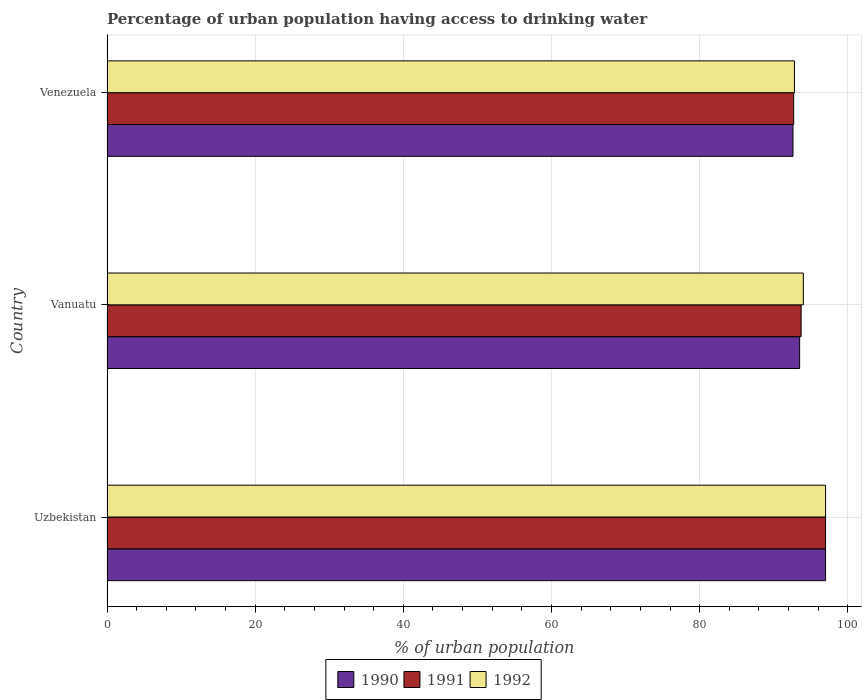What is the label of the 3rd group of bars from the top?
Make the answer very short. Uzbekistan. In how many cases, is the number of bars for a given country not equal to the number of legend labels?
Provide a short and direct response. 0. What is the percentage of urban population having access to drinking water in 1990 in Venezuela?
Your answer should be very brief. 92.6. Across all countries, what is the maximum percentage of urban population having access to drinking water in 1991?
Provide a short and direct response. 97. Across all countries, what is the minimum percentage of urban population having access to drinking water in 1990?
Your response must be concise. 92.6. In which country was the percentage of urban population having access to drinking water in 1991 maximum?
Ensure brevity in your answer.  Uzbekistan. In which country was the percentage of urban population having access to drinking water in 1990 minimum?
Provide a succinct answer. Venezuela. What is the total percentage of urban population having access to drinking water in 1990 in the graph?
Offer a terse response. 283.1. What is the difference between the percentage of urban population having access to drinking water in 1991 in Uzbekistan and the percentage of urban population having access to drinking water in 1992 in Venezuela?
Your answer should be compact. 4.2. What is the average percentage of urban population having access to drinking water in 1991 per country?
Your answer should be very brief. 94.47. What is the ratio of the percentage of urban population having access to drinking water in 1991 in Uzbekistan to that in Venezuela?
Your answer should be compact. 1.05. Is the percentage of urban population having access to drinking water in 1991 in Uzbekistan less than that in Venezuela?
Keep it short and to the point. No. Is the difference between the percentage of urban population having access to drinking water in 1992 in Vanuatu and Venezuela greater than the difference between the percentage of urban population having access to drinking water in 1990 in Vanuatu and Venezuela?
Offer a terse response. Yes. What is the difference between the highest and the second highest percentage of urban population having access to drinking water in 1992?
Make the answer very short. 3. What is the difference between the highest and the lowest percentage of urban population having access to drinking water in 1992?
Offer a very short reply. 4.2. How many countries are there in the graph?
Offer a very short reply. 3. Are the values on the major ticks of X-axis written in scientific E-notation?
Offer a terse response. No. Does the graph contain grids?
Ensure brevity in your answer.  Yes. How many legend labels are there?
Your answer should be compact. 3. What is the title of the graph?
Provide a succinct answer. Percentage of urban population having access to drinking water. Does "1971" appear as one of the legend labels in the graph?
Your response must be concise. No. What is the label or title of the X-axis?
Make the answer very short. % of urban population. What is the label or title of the Y-axis?
Your answer should be compact. Country. What is the % of urban population of 1990 in Uzbekistan?
Provide a succinct answer. 97. What is the % of urban population of 1991 in Uzbekistan?
Give a very brief answer. 97. What is the % of urban population in 1992 in Uzbekistan?
Make the answer very short. 97. What is the % of urban population of 1990 in Vanuatu?
Ensure brevity in your answer.  93.5. What is the % of urban population in 1991 in Vanuatu?
Your response must be concise. 93.7. What is the % of urban population of 1992 in Vanuatu?
Make the answer very short. 94. What is the % of urban population of 1990 in Venezuela?
Offer a very short reply. 92.6. What is the % of urban population in 1991 in Venezuela?
Your response must be concise. 92.7. What is the % of urban population in 1992 in Venezuela?
Make the answer very short. 92.8. Across all countries, what is the maximum % of urban population in 1990?
Your answer should be very brief. 97. Across all countries, what is the maximum % of urban population of 1991?
Provide a short and direct response. 97. Across all countries, what is the maximum % of urban population in 1992?
Your answer should be very brief. 97. Across all countries, what is the minimum % of urban population in 1990?
Keep it short and to the point. 92.6. Across all countries, what is the minimum % of urban population of 1991?
Provide a short and direct response. 92.7. Across all countries, what is the minimum % of urban population of 1992?
Your answer should be compact. 92.8. What is the total % of urban population of 1990 in the graph?
Ensure brevity in your answer.  283.1. What is the total % of urban population in 1991 in the graph?
Ensure brevity in your answer.  283.4. What is the total % of urban population of 1992 in the graph?
Your answer should be very brief. 283.8. What is the difference between the % of urban population of 1990 in Uzbekistan and that in Venezuela?
Your answer should be compact. 4.4. What is the difference between the % of urban population in 1991 in Vanuatu and that in Venezuela?
Provide a succinct answer. 1. What is the difference between the % of urban population of 1990 in Uzbekistan and the % of urban population of 1991 in Vanuatu?
Your response must be concise. 3.3. What is the difference between the % of urban population in 1991 in Uzbekistan and the % of urban population in 1992 in Vanuatu?
Give a very brief answer. 3. What is the difference between the % of urban population in 1990 in Uzbekistan and the % of urban population in 1991 in Venezuela?
Your answer should be very brief. 4.3. What is the difference between the % of urban population in 1990 in Uzbekistan and the % of urban population in 1992 in Venezuela?
Keep it short and to the point. 4.2. What is the difference between the % of urban population in 1991 in Uzbekistan and the % of urban population in 1992 in Venezuela?
Provide a succinct answer. 4.2. What is the difference between the % of urban population in 1990 in Vanuatu and the % of urban population in 1992 in Venezuela?
Your answer should be very brief. 0.7. What is the average % of urban population in 1990 per country?
Give a very brief answer. 94.37. What is the average % of urban population in 1991 per country?
Offer a terse response. 94.47. What is the average % of urban population in 1992 per country?
Make the answer very short. 94.6. What is the difference between the % of urban population of 1991 and % of urban population of 1992 in Uzbekistan?
Provide a succinct answer. 0. What is the difference between the % of urban population of 1990 and % of urban population of 1992 in Venezuela?
Give a very brief answer. -0.2. What is the ratio of the % of urban population of 1990 in Uzbekistan to that in Vanuatu?
Provide a short and direct response. 1.04. What is the ratio of the % of urban population in 1991 in Uzbekistan to that in Vanuatu?
Your answer should be compact. 1.04. What is the ratio of the % of urban population of 1992 in Uzbekistan to that in Vanuatu?
Ensure brevity in your answer.  1.03. What is the ratio of the % of urban population of 1990 in Uzbekistan to that in Venezuela?
Provide a short and direct response. 1.05. What is the ratio of the % of urban population of 1991 in Uzbekistan to that in Venezuela?
Your answer should be compact. 1.05. What is the ratio of the % of urban population of 1992 in Uzbekistan to that in Venezuela?
Provide a short and direct response. 1.05. What is the ratio of the % of urban population in 1990 in Vanuatu to that in Venezuela?
Provide a succinct answer. 1.01. What is the ratio of the % of urban population of 1991 in Vanuatu to that in Venezuela?
Provide a succinct answer. 1.01. What is the ratio of the % of urban population in 1992 in Vanuatu to that in Venezuela?
Give a very brief answer. 1.01. What is the difference between the highest and the second highest % of urban population of 1991?
Provide a short and direct response. 3.3. What is the difference between the highest and the second highest % of urban population in 1992?
Give a very brief answer. 3. What is the difference between the highest and the lowest % of urban population of 1990?
Your response must be concise. 4.4. What is the difference between the highest and the lowest % of urban population in 1991?
Your answer should be compact. 4.3. What is the difference between the highest and the lowest % of urban population in 1992?
Your answer should be very brief. 4.2. 